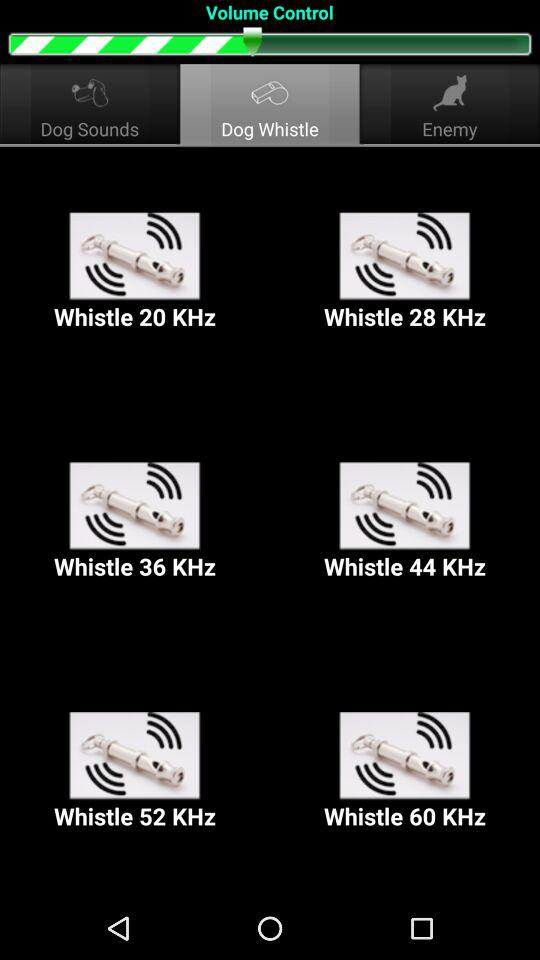Which tab is selected? The selected tab is "Dog Whistle". 